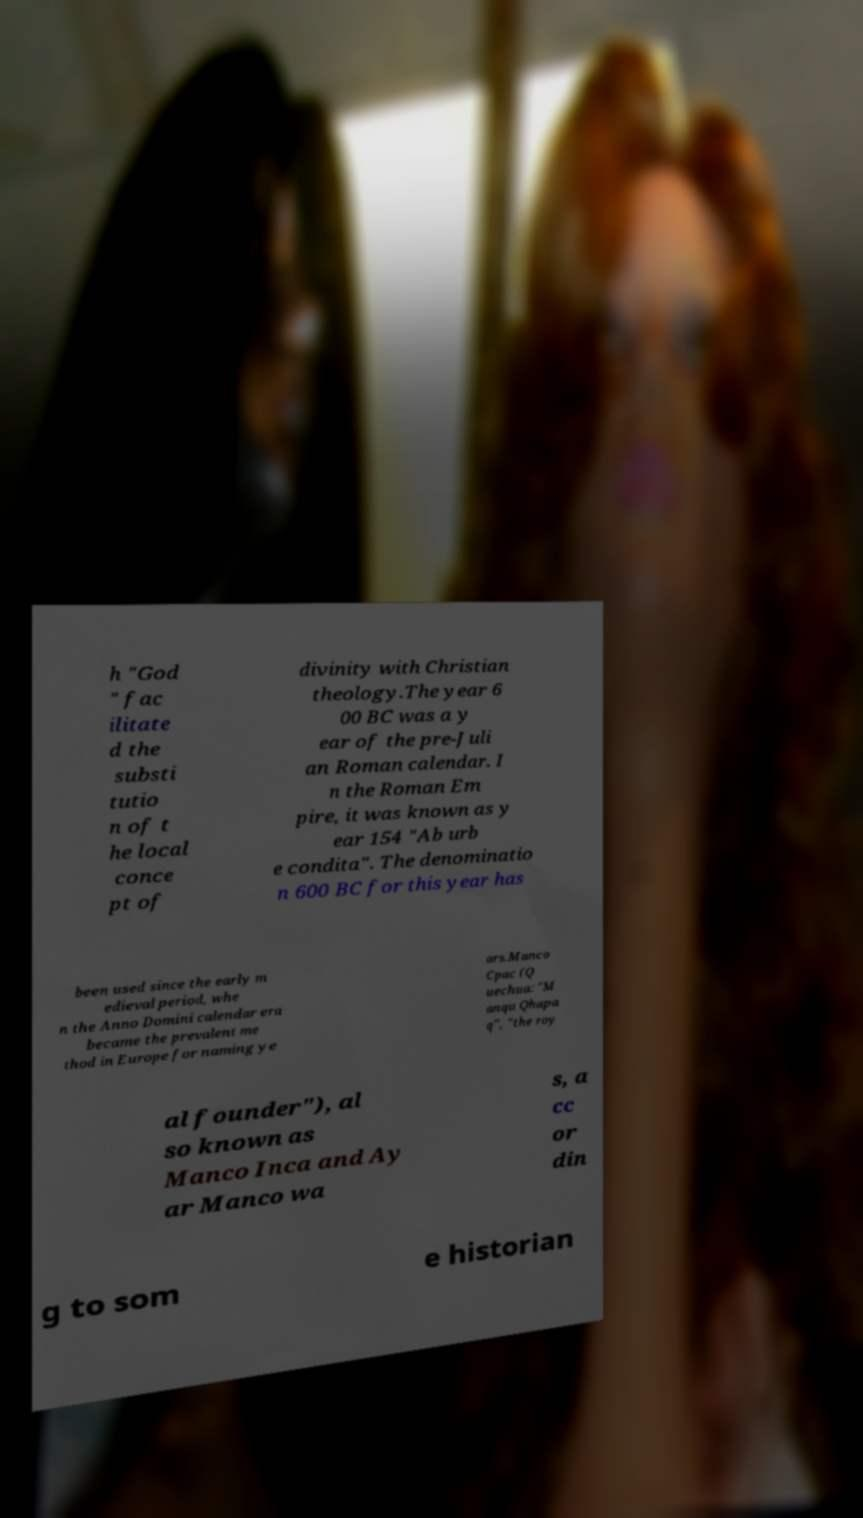What messages or text are displayed in this image? I need them in a readable, typed format. h "God " fac ilitate d the substi tutio n of t he local conce pt of divinity with Christian theology.The year 6 00 BC was a y ear of the pre-Juli an Roman calendar. I n the Roman Em pire, it was known as y ear 154 "Ab urb e condita". The denominatio n 600 BC for this year has been used since the early m edieval period, whe n the Anno Domini calendar era became the prevalent me thod in Europe for naming ye ars.Manco Cpac (Q uechua: "M anqu Qhapa q", "the roy al founder"), al so known as Manco Inca and Ay ar Manco wa s, a cc or din g to som e historian 